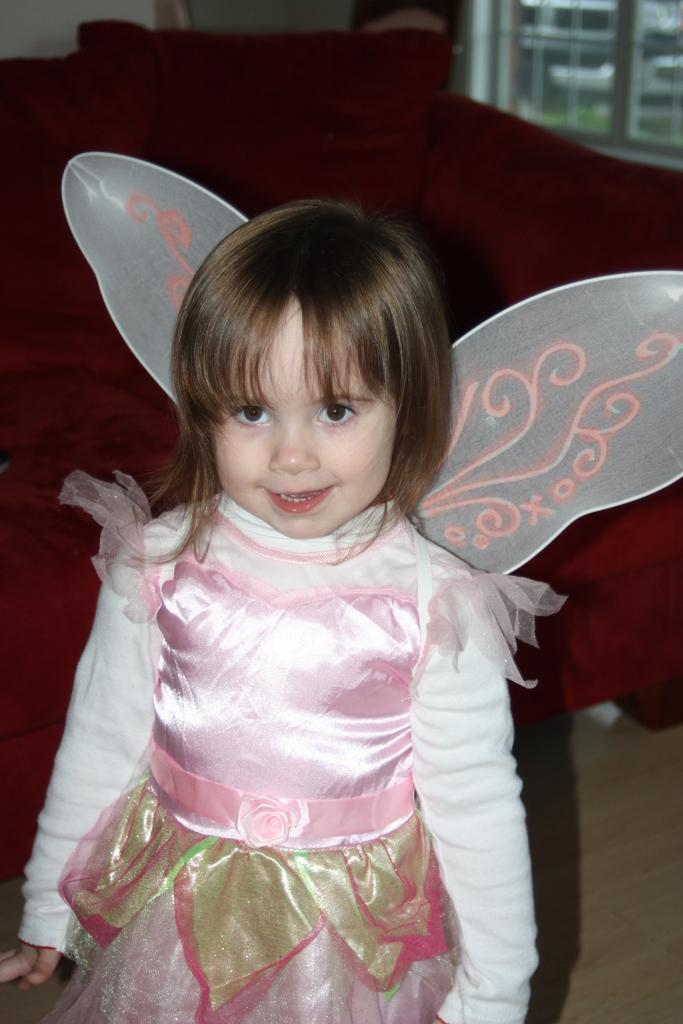Who is the main subject in the image? There is a girl in the image. What is the girl doing in the image? The girl is standing and smiling. What can be seen in the background of the image? There is a sofa, a window, and some objects in the background of the image. What type of creature is crawling on the girl's shoulder in the image? There is no creature visible on the girl's shoulder in the image. Can you tell me if the girl is a crook based on the image? The image does not provide any information about the girl's character or actions, so it cannot be determined if she is a crook or not. 